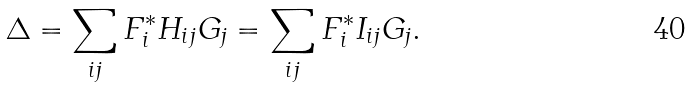Convert formula to latex. <formula><loc_0><loc_0><loc_500><loc_500>\Delta = \sum _ { i j } F _ { i } ^ { * } H _ { i j } G _ { j } = \sum _ { i j } F _ { i } ^ { * } I _ { i j } G _ { j } .</formula> 